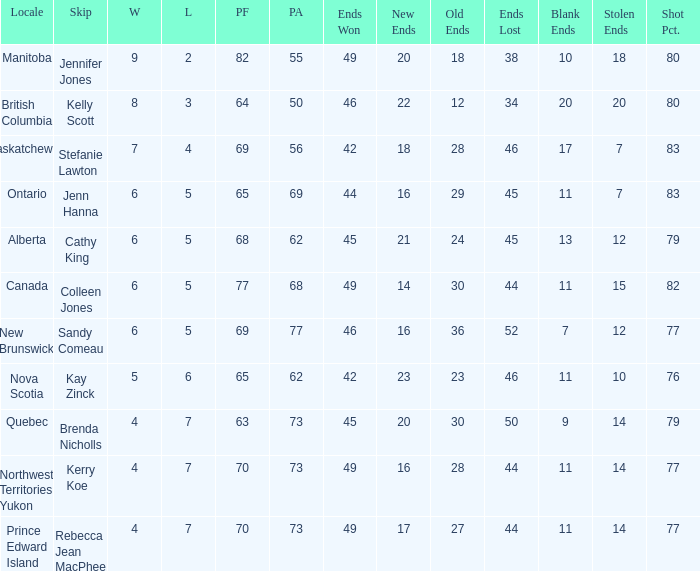What is the PA when the skip is Colleen Jones? 68.0. 